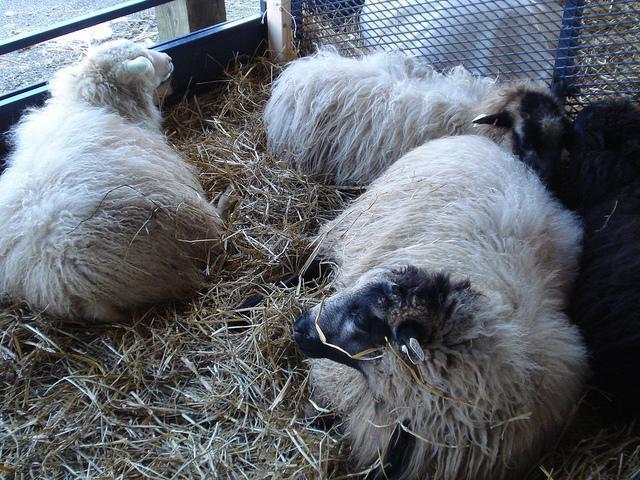How many sheep can you see?
Give a very brief answer. 4. How many people are jumping on a skateboard?
Give a very brief answer. 0. 